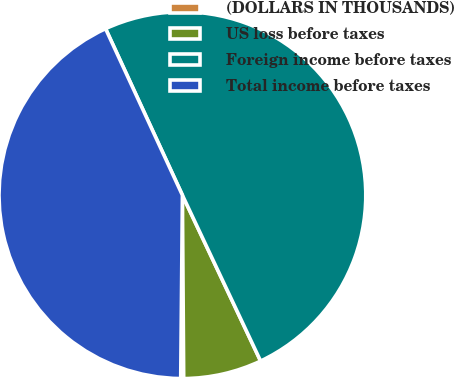Convert chart. <chart><loc_0><loc_0><loc_500><loc_500><pie_chart><fcel>(DOLLARS IN THOUSANDS)<fcel>US loss before taxes<fcel>Foreign income before taxes<fcel>Total income before taxes<nl><fcel>0.26%<fcel>6.9%<fcel>49.87%<fcel>42.97%<nl></chart> 